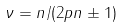Convert formula to latex. <formula><loc_0><loc_0><loc_500><loc_500>\nu = n / ( 2 p n \pm 1 )</formula> 